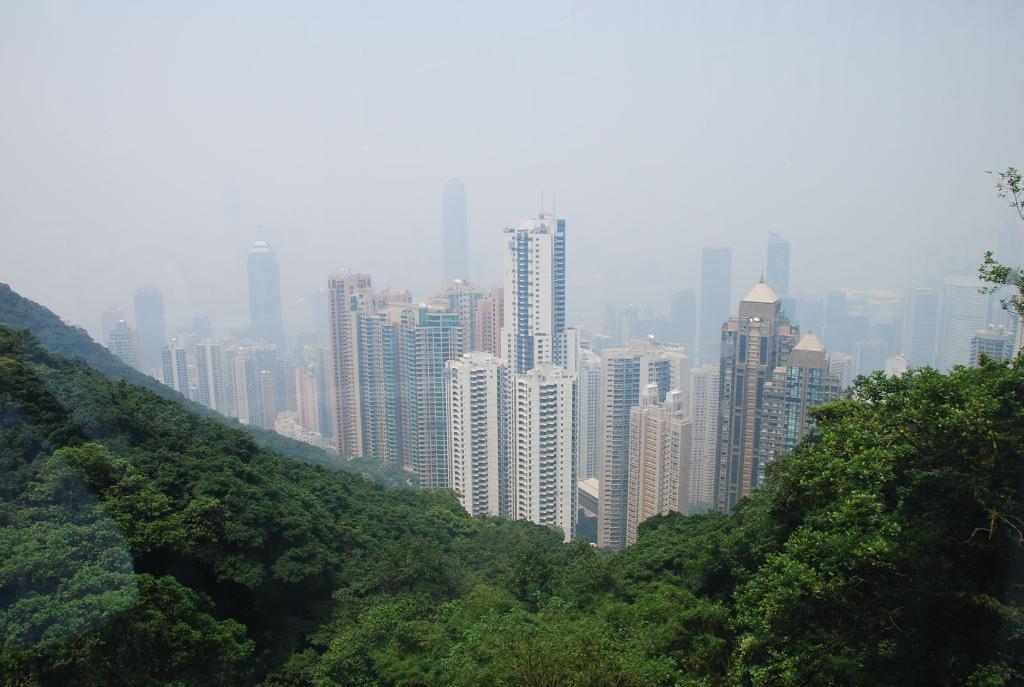Can you describe this image briefly? This image is taken from the top most view where we can see there are so many buildings one beside the other. At the bottom there are hills on which there are trees. We can see the overall view of the city. 